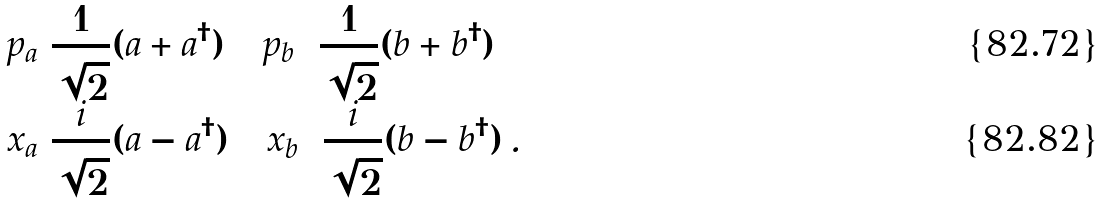Convert formula to latex. <formula><loc_0><loc_0><loc_500><loc_500>p _ { a } = & \frac { 1 } { \sqrt { 2 } } ( a + a ^ { \dagger } ) \quad p _ { b } = \frac { 1 } { \sqrt { 2 } } ( b + b ^ { \dagger } ) \\ x _ { a } = & \frac { i } { \sqrt { 2 } } ( a - a ^ { \dagger } ) \quad x _ { b } = \frac { i } { \sqrt { 2 } } ( b - b ^ { \dagger } ) \, .</formula> 